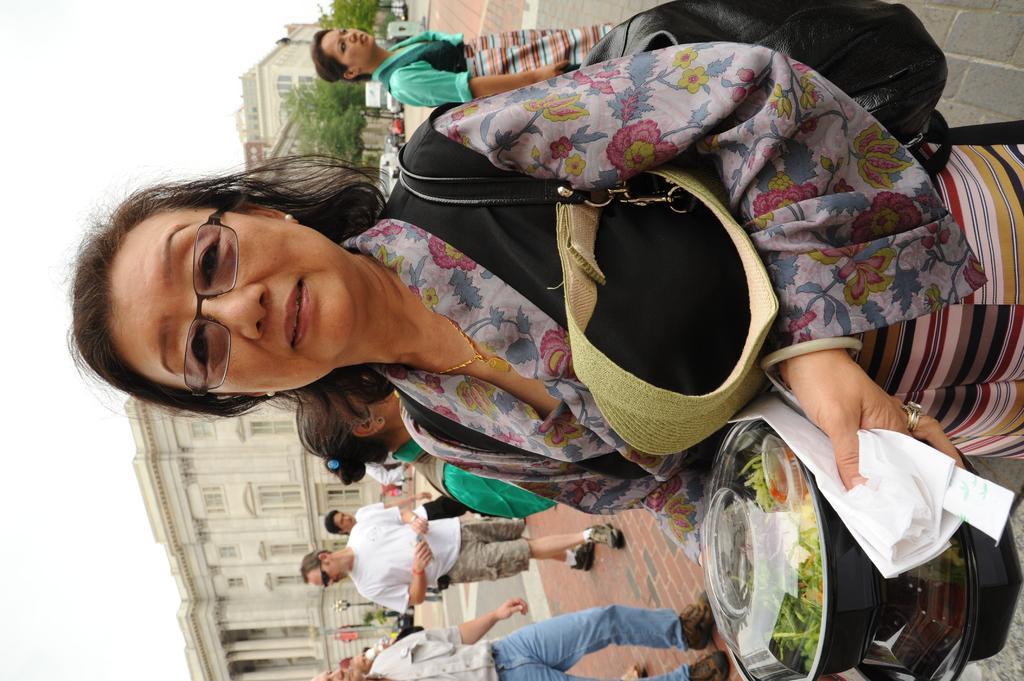Describe this image in one or two sentences. In this image there is one women standing in middle of this image and holding a food containers. There are some persons behind to this woman. As we can see there are some buildings in the background. There is a sky on the left side of this image. 